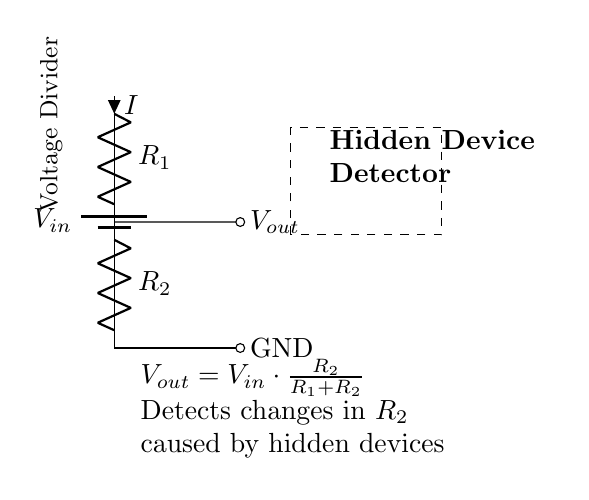What is the role of R1 in this circuit? R1 acts as the first resistor in the voltage divider, allowing the input voltage to be divided across R1 and R2.
Answer: First resistor What is the output voltage Vout formula? The formula for Vout is derived from the voltage divider principle, given as Vout = Vin * (R2 / (R1 + R2)).
Answer: Vout = Vin * (R2 / (R1 + R2)) What does the dashed rectangle signify? The dashed rectangle indicates the area where the hidden device detector is positioned, showing the functional region of the sensor.
Answer: Detector area If R2 decreases, what happens to Vout? If R2 decreases, Vout decreases because it is directly proportional to R2. Lowering R2 reduces the fraction of Vin that appears at the output.
Answer: Vout decreases What type of circuit is this? This is a voltage divider circuit, which specifically divides the voltage based on the resistor values.
Answer: Voltage divider What signifies the ground in this circuit? The circuit ground is indicated by the short line labeled GND, which provides a reference point for the voltage measurements taken in the circuit.
Answer: GND What does R2 detect in this system? R2 detects changes in resistance caused by the presence of hidden recording devices, allowing for their detection based on changes in output voltage.
Answer: Hidden devices 